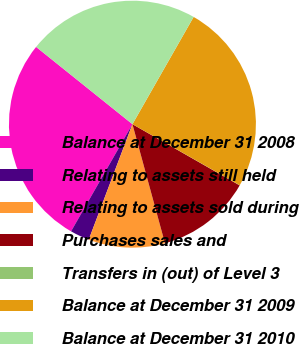<chart> <loc_0><loc_0><loc_500><loc_500><pie_chart><fcel>Balance at December 31 2008<fcel>Relating to assets still held<fcel>Relating to assets sold during<fcel>Purchases sales and<fcel>Transfers in (out) of Level 3<fcel>Balance at December 31 2009<fcel>Balance at December 31 2010<nl><fcel>27.48%<fcel>2.52%<fcel>10.0%<fcel>12.5%<fcel>0.02%<fcel>24.98%<fcel>22.49%<nl></chart> 